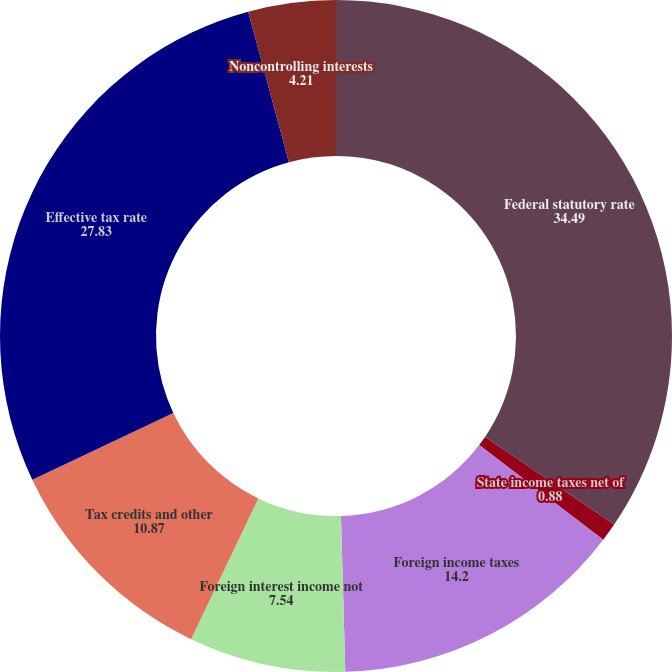<chart> <loc_0><loc_0><loc_500><loc_500><pie_chart><fcel>Federal statutory rate<fcel>State income taxes net of<fcel>Foreign income taxes<fcel>Foreign interest income not<fcel>Tax credits and other<fcel>Effective tax rate<fcel>Noncontrolling interests<nl><fcel>34.49%<fcel>0.88%<fcel>14.2%<fcel>7.54%<fcel>10.87%<fcel>27.83%<fcel>4.21%<nl></chart> 